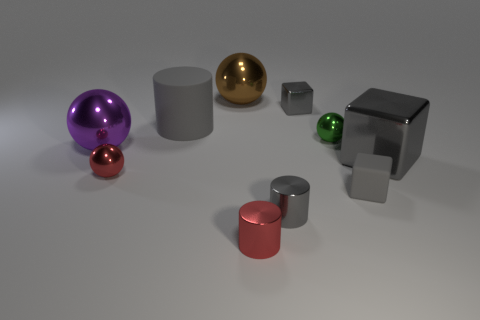Can you describe the arrangement of these objects? The objects are arranged in an almost scattered pattern across the flat surface. Some are positioned close together, others more spaced apart, creating a visually balanced yet varied composition. Does this arrangement serve a particular purpose? The purpose isn't immediately clear; it could be purely aesthetic, demonstrating the contrast in shapes and sizes, or possibly a setup for some form of visual experiment or display. 